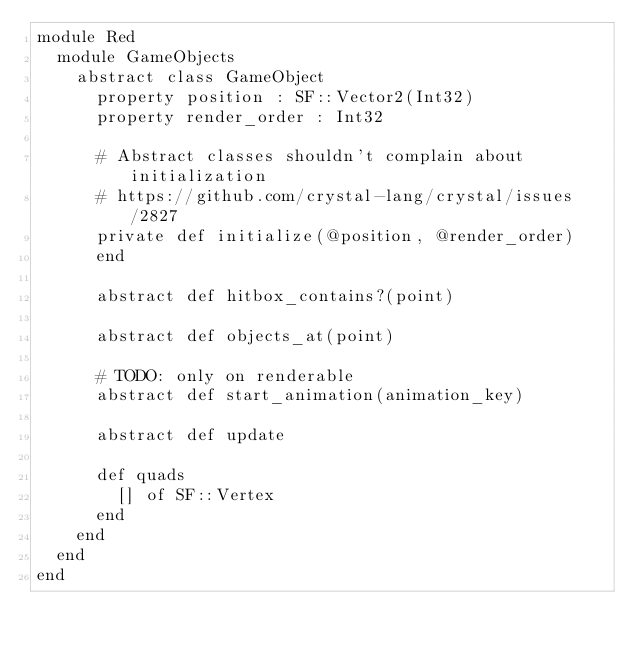Convert code to text. <code><loc_0><loc_0><loc_500><loc_500><_Crystal_>module Red
  module GameObjects
    abstract class GameObject
      property position : SF::Vector2(Int32)
      property render_order : Int32

      # Abstract classes shouldn't complain about initialization
      # https://github.com/crystal-lang/crystal/issues/2827
      private def initialize(@position, @render_order)
      end

      abstract def hitbox_contains?(point)

      abstract def objects_at(point)

      # TODO: only on renderable
      abstract def start_animation(animation_key)

      abstract def update

      def quads
        [] of SF::Vertex
      end
    end
  end
end
</code> 